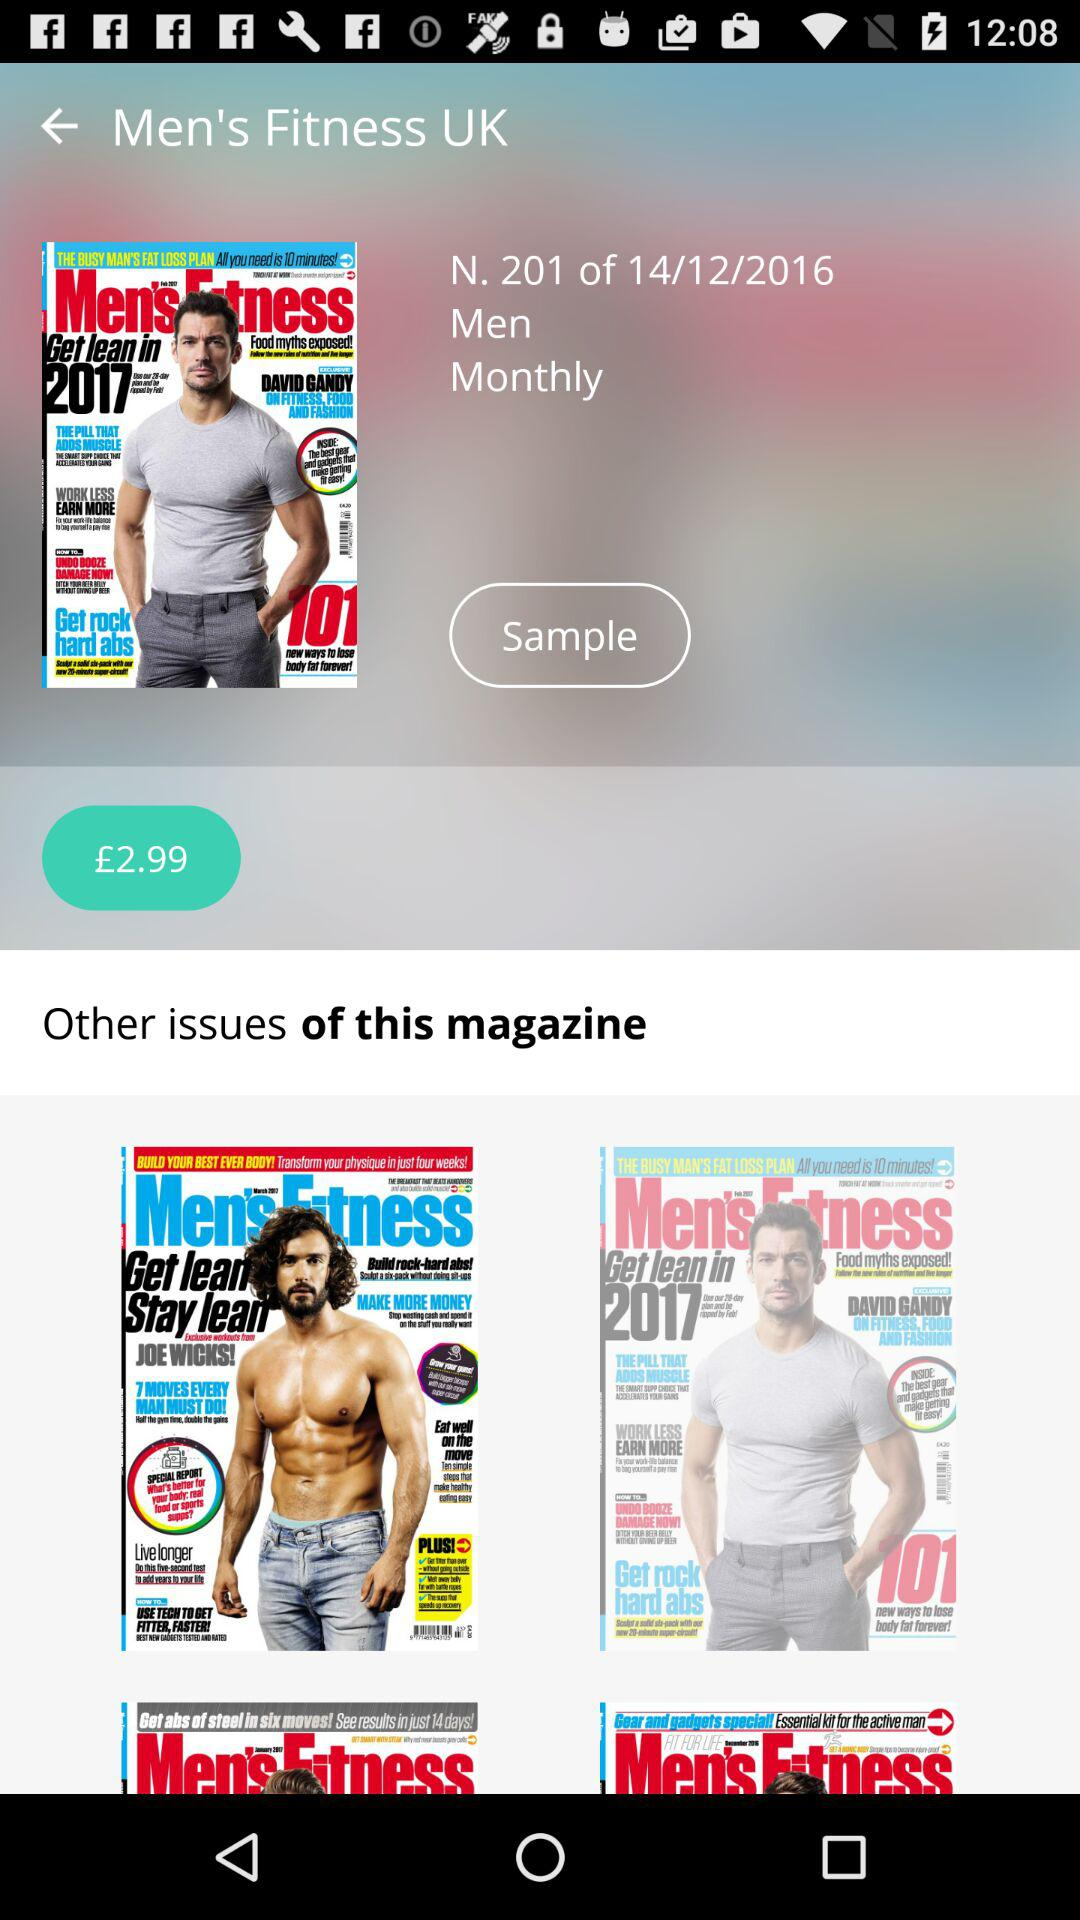What is the price of the magazine? The price is £2.99. 